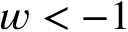Convert formula to latex. <formula><loc_0><loc_0><loc_500><loc_500>w < - 1</formula> 